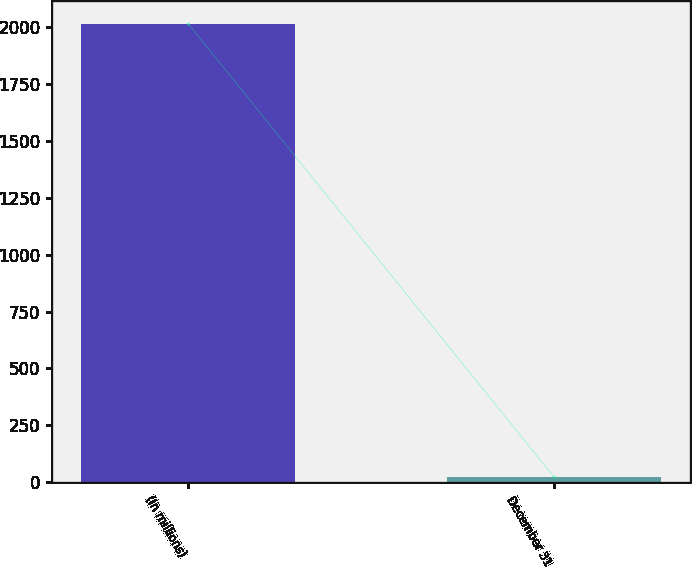Convert chart to OTSL. <chart><loc_0><loc_0><loc_500><loc_500><bar_chart><fcel>(In millions)<fcel>December 31<nl><fcel>2017<fcel>23.3<nl></chart> 